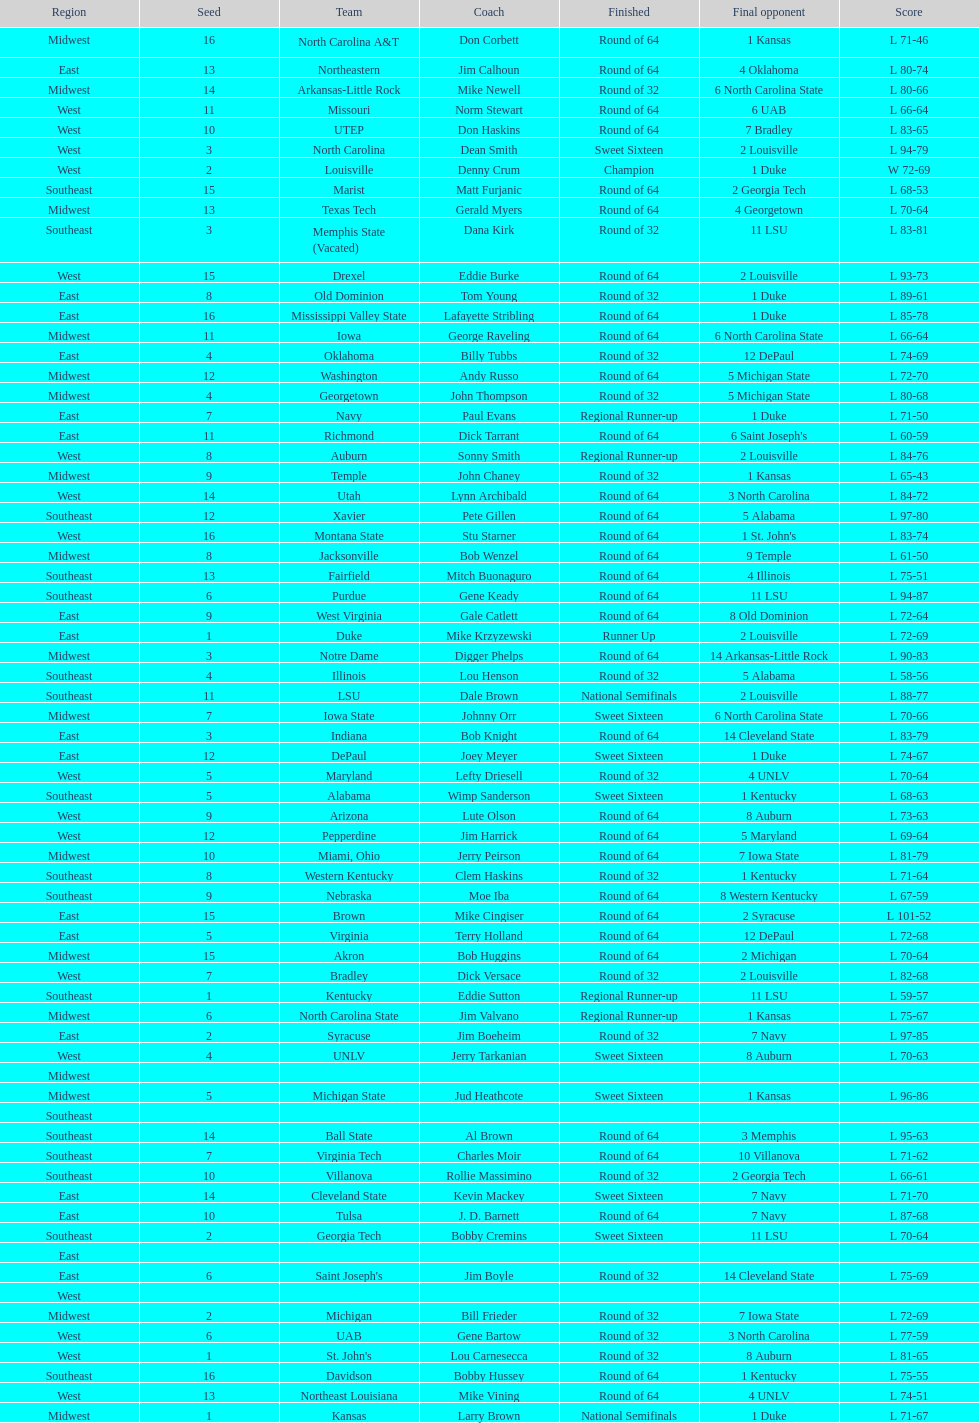What region is listed before the midwest? West. 